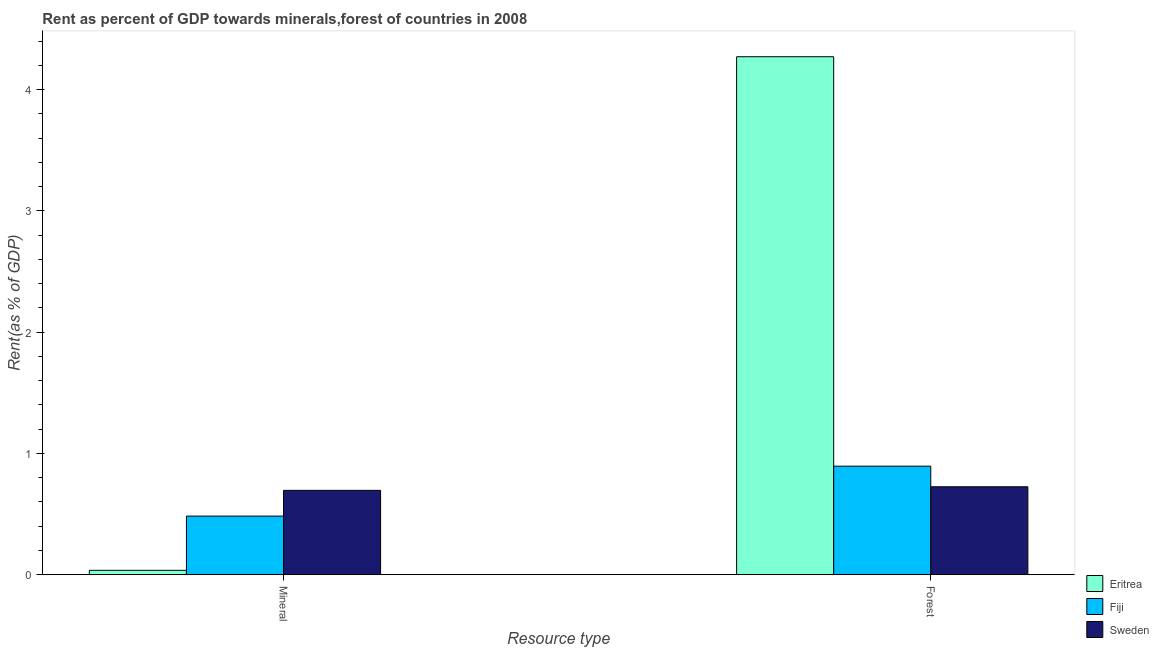How many different coloured bars are there?
Your answer should be very brief. 3. How many groups of bars are there?
Make the answer very short. 2. Are the number of bars per tick equal to the number of legend labels?
Provide a short and direct response. Yes. Are the number of bars on each tick of the X-axis equal?
Offer a terse response. Yes. How many bars are there on the 2nd tick from the left?
Keep it short and to the point. 3. How many bars are there on the 2nd tick from the right?
Provide a succinct answer. 3. What is the label of the 2nd group of bars from the left?
Your answer should be very brief. Forest. What is the mineral rent in Eritrea?
Make the answer very short. 0.04. Across all countries, what is the maximum mineral rent?
Ensure brevity in your answer.  0.7. Across all countries, what is the minimum mineral rent?
Make the answer very short. 0.04. In which country was the forest rent maximum?
Offer a terse response. Eritrea. What is the total mineral rent in the graph?
Offer a very short reply. 1.21. What is the difference between the forest rent in Fiji and that in Eritrea?
Keep it short and to the point. -3.38. What is the difference between the forest rent in Sweden and the mineral rent in Fiji?
Ensure brevity in your answer.  0.24. What is the average mineral rent per country?
Provide a short and direct response. 0.4. What is the difference between the forest rent and mineral rent in Fiji?
Ensure brevity in your answer.  0.41. What is the ratio of the mineral rent in Fiji to that in Sweden?
Ensure brevity in your answer.  0.69. Is the forest rent in Sweden less than that in Eritrea?
Keep it short and to the point. Yes. In how many countries, is the mineral rent greater than the average mineral rent taken over all countries?
Your answer should be compact. 2. What does the 2nd bar from the left in Forest represents?
Your answer should be compact. Fiji. What is the difference between two consecutive major ticks on the Y-axis?
Make the answer very short. 1. Does the graph contain grids?
Provide a short and direct response. No. Where does the legend appear in the graph?
Ensure brevity in your answer.  Bottom right. What is the title of the graph?
Provide a short and direct response. Rent as percent of GDP towards minerals,forest of countries in 2008. What is the label or title of the X-axis?
Your response must be concise. Resource type. What is the label or title of the Y-axis?
Give a very brief answer. Rent(as % of GDP). What is the Rent(as % of GDP) in Eritrea in Mineral?
Your answer should be very brief. 0.04. What is the Rent(as % of GDP) in Fiji in Mineral?
Provide a short and direct response. 0.48. What is the Rent(as % of GDP) of Sweden in Mineral?
Your answer should be very brief. 0.7. What is the Rent(as % of GDP) in Eritrea in Forest?
Ensure brevity in your answer.  4.27. What is the Rent(as % of GDP) in Fiji in Forest?
Keep it short and to the point. 0.89. What is the Rent(as % of GDP) of Sweden in Forest?
Ensure brevity in your answer.  0.73. Across all Resource type, what is the maximum Rent(as % of GDP) of Eritrea?
Offer a very short reply. 4.27. Across all Resource type, what is the maximum Rent(as % of GDP) of Fiji?
Offer a very short reply. 0.89. Across all Resource type, what is the maximum Rent(as % of GDP) of Sweden?
Make the answer very short. 0.73. Across all Resource type, what is the minimum Rent(as % of GDP) in Eritrea?
Provide a succinct answer. 0.04. Across all Resource type, what is the minimum Rent(as % of GDP) of Fiji?
Keep it short and to the point. 0.48. Across all Resource type, what is the minimum Rent(as % of GDP) in Sweden?
Your response must be concise. 0.7. What is the total Rent(as % of GDP) in Eritrea in the graph?
Provide a succinct answer. 4.31. What is the total Rent(as % of GDP) of Fiji in the graph?
Provide a short and direct response. 1.38. What is the total Rent(as % of GDP) of Sweden in the graph?
Your answer should be very brief. 1.42. What is the difference between the Rent(as % of GDP) in Eritrea in Mineral and that in Forest?
Provide a short and direct response. -4.24. What is the difference between the Rent(as % of GDP) of Fiji in Mineral and that in Forest?
Your answer should be very brief. -0.41. What is the difference between the Rent(as % of GDP) of Sweden in Mineral and that in Forest?
Your answer should be compact. -0.03. What is the difference between the Rent(as % of GDP) in Eritrea in Mineral and the Rent(as % of GDP) in Fiji in Forest?
Ensure brevity in your answer.  -0.86. What is the difference between the Rent(as % of GDP) of Eritrea in Mineral and the Rent(as % of GDP) of Sweden in Forest?
Keep it short and to the point. -0.69. What is the difference between the Rent(as % of GDP) in Fiji in Mineral and the Rent(as % of GDP) in Sweden in Forest?
Provide a succinct answer. -0.24. What is the average Rent(as % of GDP) in Eritrea per Resource type?
Your answer should be compact. 2.15. What is the average Rent(as % of GDP) of Fiji per Resource type?
Your answer should be compact. 0.69. What is the average Rent(as % of GDP) in Sweden per Resource type?
Your response must be concise. 0.71. What is the difference between the Rent(as % of GDP) of Eritrea and Rent(as % of GDP) of Fiji in Mineral?
Your answer should be compact. -0.45. What is the difference between the Rent(as % of GDP) in Eritrea and Rent(as % of GDP) in Sweden in Mineral?
Offer a terse response. -0.66. What is the difference between the Rent(as % of GDP) of Fiji and Rent(as % of GDP) of Sweden in Mineral?
Provide a short and direct response. -0.21. What is the difference between the Rent(as % of GDP) in Eritrea and Rent(as % of GDP) in Fiji in Forest?
Ensure brevity in your answer.  3.38. What is the difference between the Rent(as % of GDP) of Eritrea and Rent(as % of GDP) of Sweden in Forest?
Keep it short and to the point. 3.55. What is the difference between the Rent(as % of GDP) of Fiji and Rent(as % of GDP) of Sweden in Forest?
Provide a short and direct response. 0.17. What is the ratio of the Rent(as % of GDP) in Eritrea in Mineral to that in Forest?
Keep it short and to the point. 0.01. What is the ratio of the Rent(as % of GDP) in Fiji in Mineral to that in Forest?
Ensure brevity in your answer.  0.54. What is the ratio of the Rent(as % of GDP) in Sweden in Mineral to that in Forest?
Make the answer very short. 0.96. What is the difference between the highest and the second highest Rent(as % of GDP) of Eritrea?
Your answer should be very brief. 4.24. What is the difference between the highest and the second highest Rent(as % of GDP) in Fiji?
Make the answer very short. 0.41. What is the difference between the highest and the second highest Rent(as % of GDP) in Sweden?
Ensure brevity in your answer.  0.03. What is the difference between the highest and the lowest Rent(as % of GDP) of Eritrea?
Give a very brief answer. 4.24. What is the difference between the highest and the lowest Rent(as % of GDP) of Fiji?
Make the answer very short. 0.41. What is the difference between the highest and the lowest Rent(as % of GDP) of Sweden?
Your answer should be very brief. 0.03. 